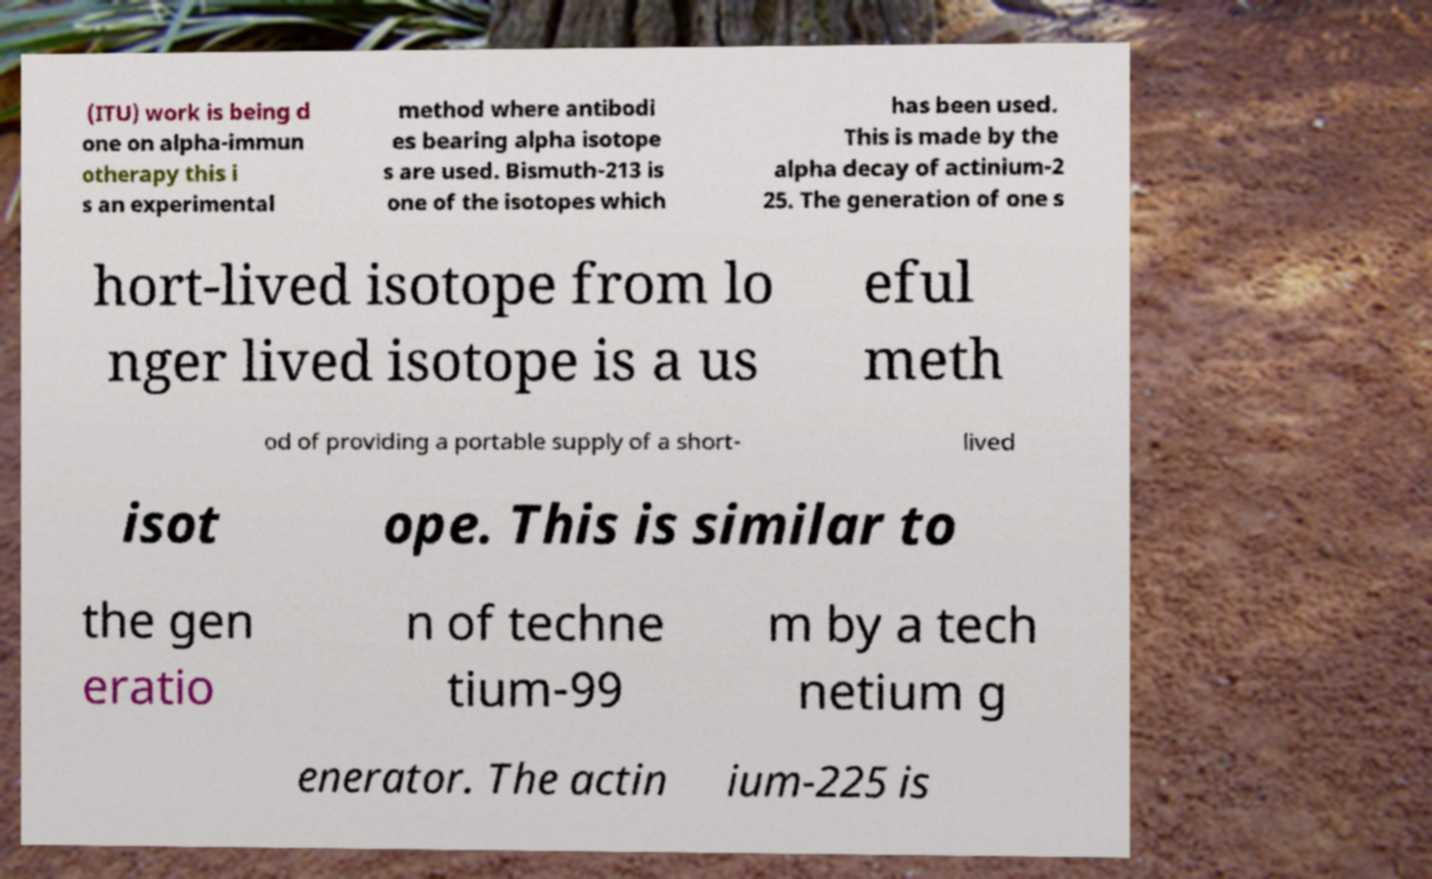What messages or text are displayed in this image? I need them in a readable, typed format. (ITU) work is being d one on alpha-immun otherapy this i s an experimental method where antibodi es bearing alpha isotope s are used. Bismuth-213 is one of the isotopes which has been used. This is made by the alpha decay of actinium-2 25. The generation of one s hort-lived isotope from lo nger lived isotope is a us eful meth od of providing a portable supply of a short- lived isot ope. This is similar to the gen eratio n of techne tium-99 m by a tech netium g enerator. The actin ium-225 is 